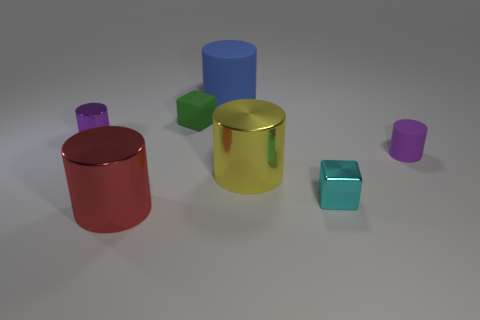How does the lighting in the scene affect the appearance of the objects? The lighting in this scene is casting soft shadows and giving the objects a slightly reflective sheen. It creates a sense of depth and three-dimensionality, while also subtly highlighting the texture differences among the objects. 